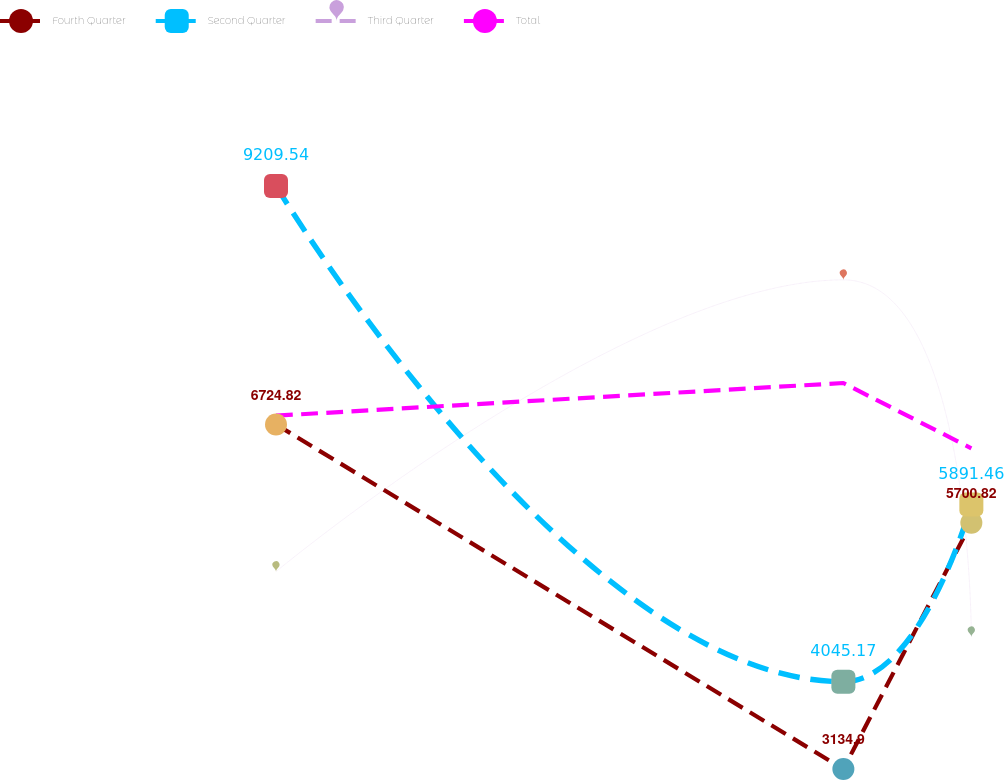<chart> <loc_0><loc_0><loc_500><loc_500><line_chart><ecel><fcel>Fourth Quarter<fcel>Second Quarter<fcel>Third Quarter<fcel>Total<nl><fcel>1817.76<fcel>6724.82<fcel>9209.54<fcel>5191.85<fcel>6815.79<nl><fcel>1983.74<fcel>3134.9<fcel>4045.17<fcel>8230.75<fcel>7156.26<nl><fcel>2021.18<fcel>5700.82<fcel>5891.46<fcel>4512<fcel>6475.32<nl><fcel>2192.21<fcel>8321.9<fcel>4561.61<fcel>6993.67<fcel>3642.04<nl></chart> 